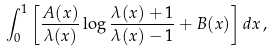<formula> <loc_0><loc_0><loc_500><loc_500>\int _ { 0 } ^ { 1 } \left [ \frac { A ( x ) } { \lambda ( x ) } \log \frac { \lambda ( x ) + 1 } { \lambda ( x ) - 1 } + B ( x ) \right ] d x \, ,</formula> 